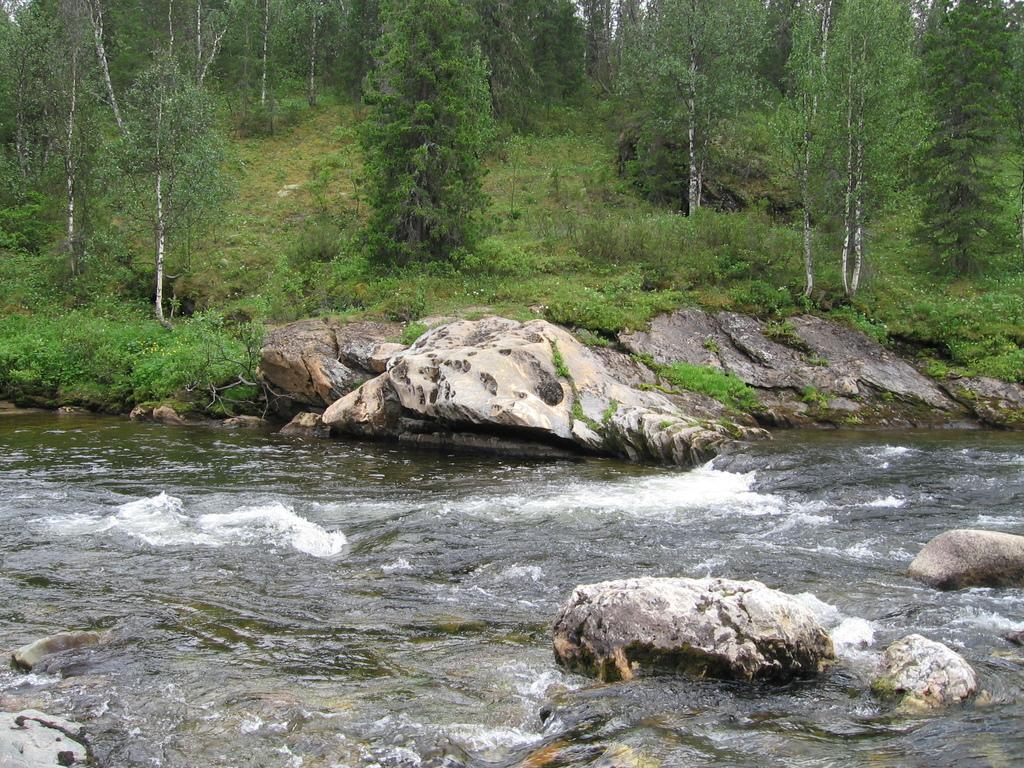What is the primary element visible in the image? There is water in the image. What can be seen in the distance in the image? There are trees in the background of the image. What type of horn can be seen on the trees in the image? There are no horns present in the image, and the trees do not have any horns. 